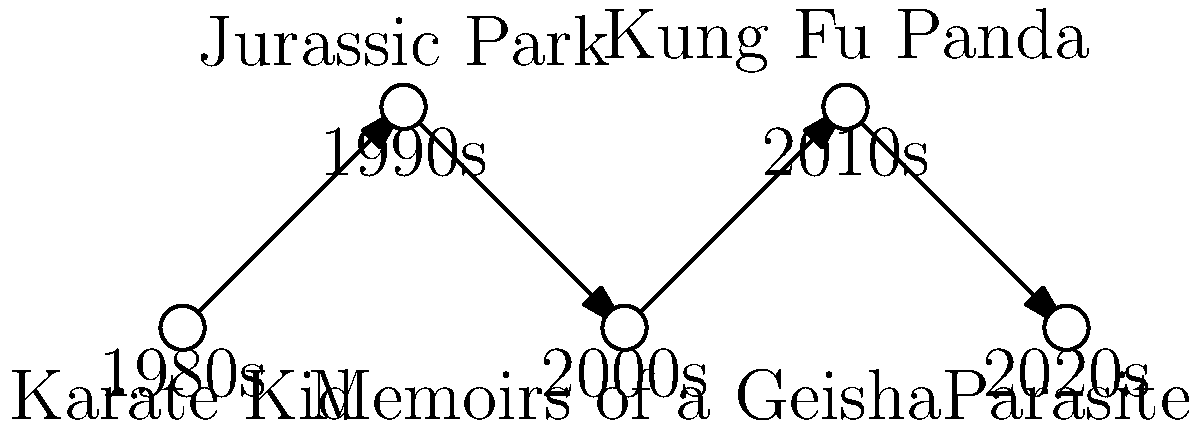Based on the network diagram showing the evolution of loanwords in movie titles across decades, which decade marks the shift towards incorporating more diverse cultural elements in mainstream Hollywood titles? To answer this question, we need to analyze the network diagram and the movie titles provided for each decade:

1. 1980s: "Karate Kid" - This title includes the Japanese loanword "karate," but it's a relatively well-established term in English.

2. 1990s: "Jurassic Park" - While "jurassic" is derived from Greek/Latin, it doesn't represent a significant shift in cultural diversity.

3. 2000s: "Memoirs of a Geisha" - This title incorporates the Japanese word "geisha," showing an increase in using culturally specific terms.

4. 2010s: "Kung Fu Panda" - This title combines the Chinese term "kung fu" with "panda," representing a more overt use of culturally diverse elements.

5. 2020s: "Parasite" - While not a loanword itself, this is a Korean film that gained mainstream success in Hollywood, representing a shift towards global cinema integration.

The shift towards incorporating more diverse cultural elements becomes apparent in the 2000s with "Memoirs of a Geisha" and becomes more pronounced in the 2010s with "Kung Fu Panda." The trend continues into the 2020s with the success of non-English language films like "Parasite" in mainstream Hollywood.

Therefore, the 2000s mark the beginning of this shift, which becomes more established in subsequent decades.
Answer: 2000s 